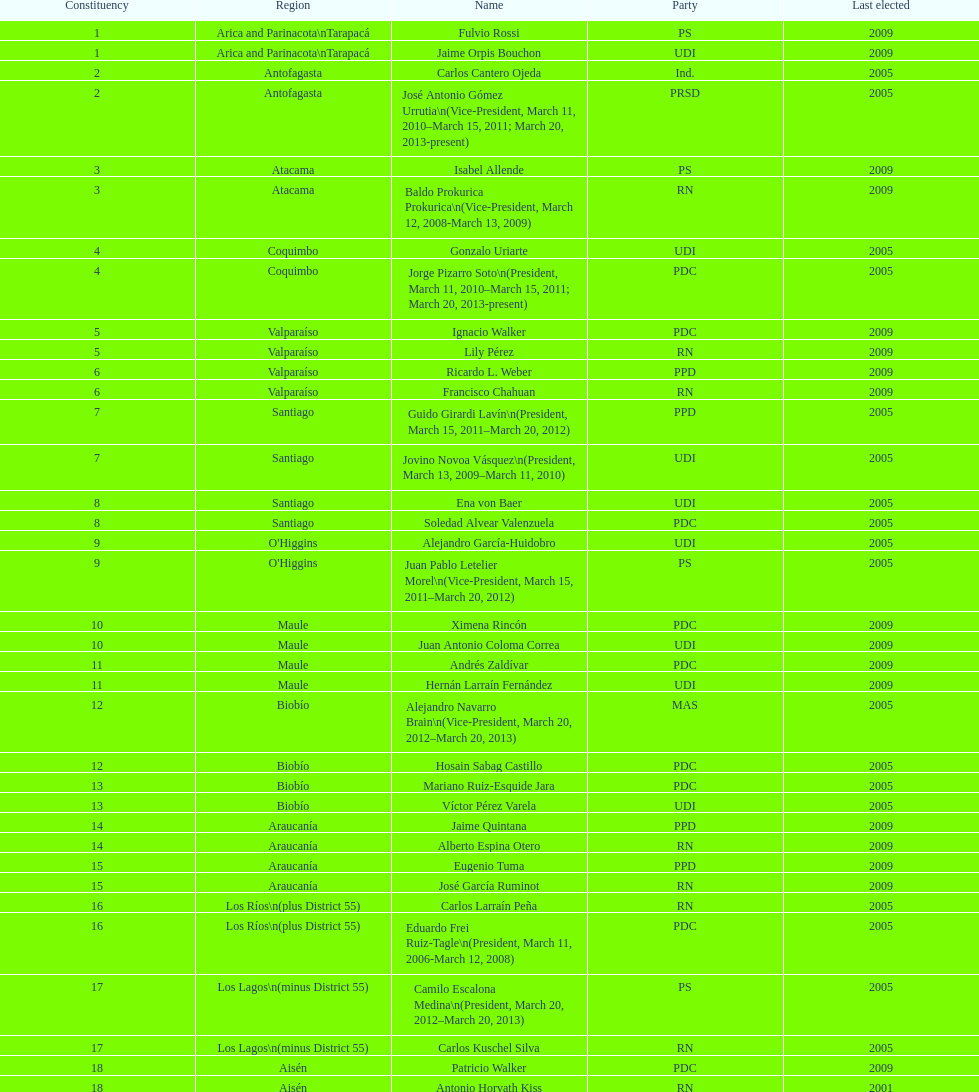What is the concluding region presented in the table? Magallanes. 